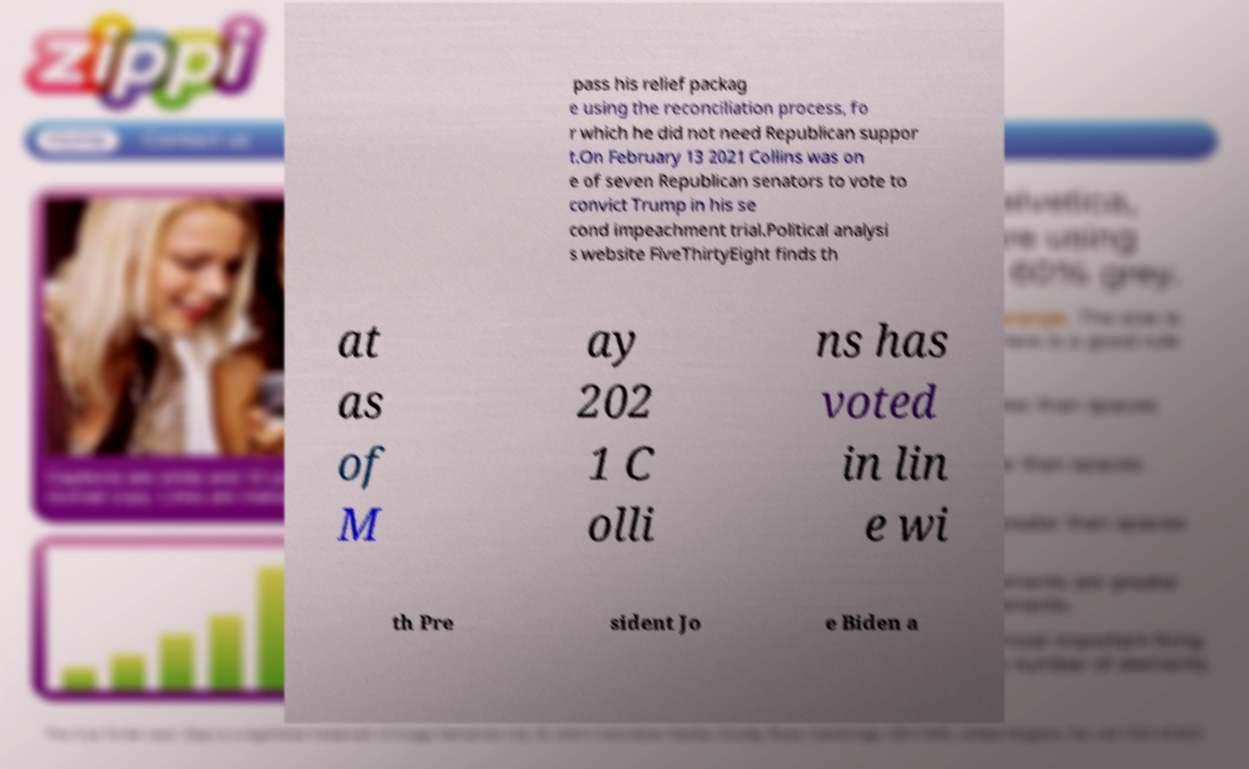For documentation purposes, I need the text within this image transcribed. Could you provide that? pass his relief packag e using the reconciliation process, fo r which he did not need Republican suppor t.On February 13 2021 Collins was on e of seven Republican senators to vote to convict Trump in his se cond impeachment trial.Political analysi s website FiveThirtyEight finds th at as of M ay 202 1 C olli ns has voted in lin e wi th Pre sident Jo e Biden a 